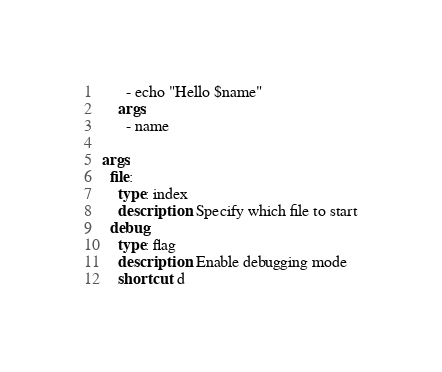Convert code to text. <code><loc_0><loc_0><loc_500><loc_500><_YAML_>      - echo "Hello $name"
    args: 
      - name

args:
  file:
    type: index
    description: Specify which file to start
  debug:
    type: flag
    description: Enable debugging mode
    shortcut: d</code> 